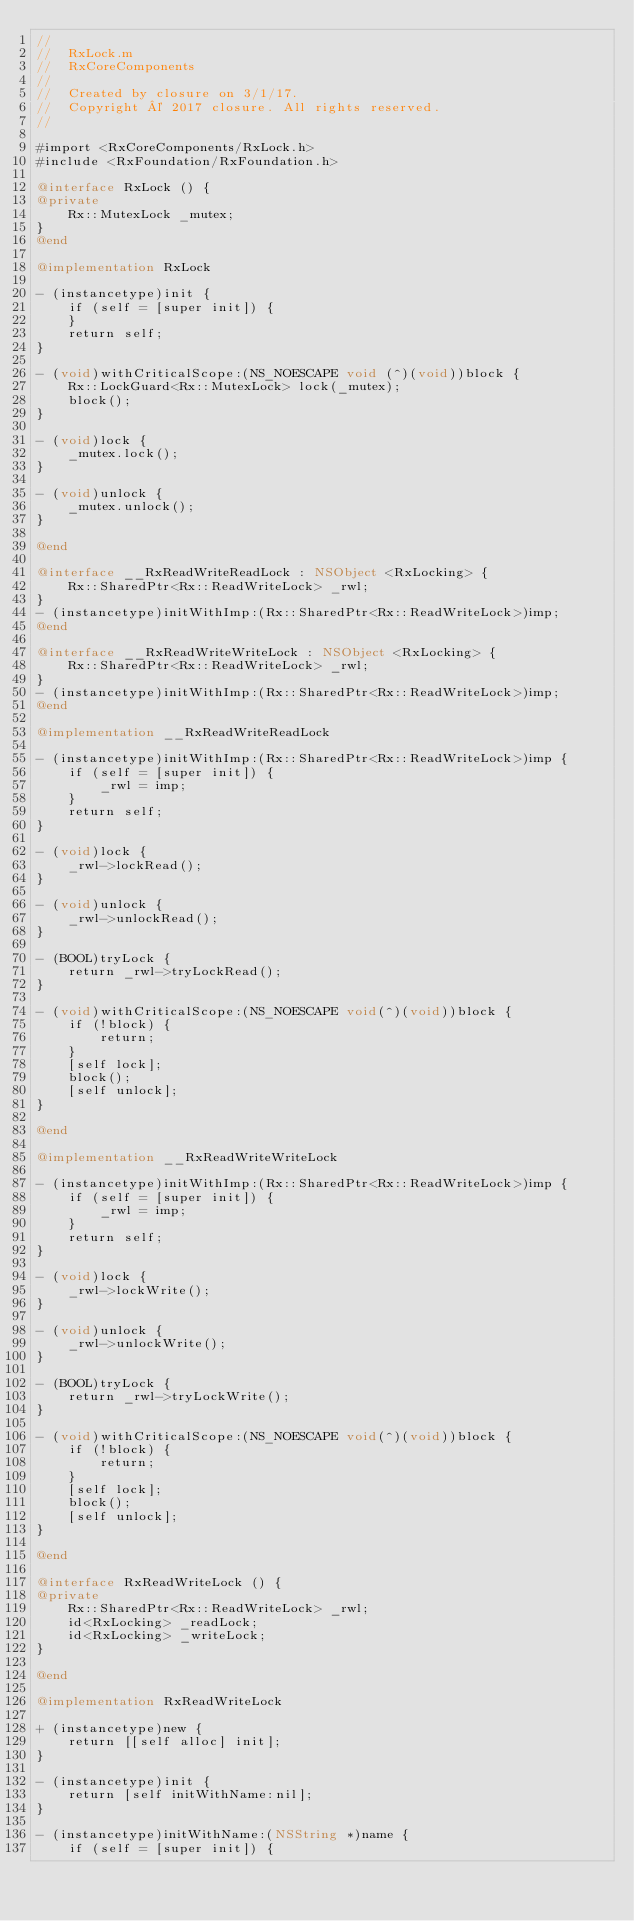<code> <loc_0><loc_0><loc_500><loc_500><_ObjectiveC_>//
//  RxLock.m
//  RxCoreComponents
//
//  Created by closure on 3/1/17.
//  Copyright © 2017 closure. All rights reserved.
//

#import <RxCoreComponents/RxLock.h>
#include <RxFoundation/RxFoundation.h>

@interface RxLock () {
@private
    Rx::MutexLock _mutex;
}
@end

@implementation RxLock

- (instancetype)init {
    if (self = [super init]) {
    }
    return self;
}

- (void)withCriticalScope:(NS_NOESCAPE void (^)(void))block {
    Rx::LockGuard<Rx::MutexLock> lock(_mutex);
    block();
}

- (void)lock {
    _mutex.lock();
}

- (void)unlock {
    _mutex.unlock();
}

@end

@interface __RxReadWriteReadLock : NSObject <RxLocking> {
    Rx::SharedPtr<Rx::ReadWriteLock> _rwl;
}
- (instancetype)initWithImp:(Rx::SharedPtr<Rx::ReadWriteLock>)imp;
@end

@interface __RxReadWriteWriteLock : NSObject <RxLocking> {
    Rx::SharedPtr<Rx::ReadWriteLock> _rwl;
}
- (instancetype)initWithImp:(Rx::SharedPtr<Rx::ReadWriteLock>)imp;
@end

@implementation __RxReadWriteReadLock

- (instancetype)initWithImp:(Rx::SharedPtr<Rx::ReadWriteLock>)imp {
    if (self = [super init]) {
        _rwl = imp;
    }
    return self;
}

- (void)lock {
    _rwl->lockRead();
}

- (void)unlock {
    _rwl->unlockRead();
}

- (BOOL)tryLock {
    return _rwl->tryLockRead();
}

- (void)withCriticalScope:(NS_NOESCAPE void(^)(void))block {
    if (!block) {
        return;
    }
    [self lock];
    block();
    [self unlock];
}

@end

@implementation __RxReadWriteWriteLock

- (instancetype)initWithImp:(Rx::SharedPtr<Rx::ReadWriteLock>)imp {
    if (self = [super init]) {
        _rwl = imp;
    }
    return self;
}

- (void)lock {
    _rwl->lockWrite();
}

- (void)unlock {
    _rwl->unlockWrite();
}

- (BOOL)tryLock {
    return _rwl->tryLockWrite();
}

- (void)withCriticalScope:(NS_NOESCAPE void(^)(void))block {
    if (!block) {
        return;
    }
    [self lock];
    block();
    [self unlock];
}

@end

@interface RxReadWriteLock () {
@private
    Rx::SharedPtr<Rx::ReadWriteLock> _rwl;
    id<RxLocking> _readLock;
    id<RxLocking> _writeLock;
}

@end

@implementation RxReadWriteLock

+ (instancetype)new {
    return [[self alloc] init];
}

- (instancetype)init {
    return [self initWithName:nil];
}

- (instancetype)initWithName:(NSString *)name {
    if (self = [super init]) {</code> 